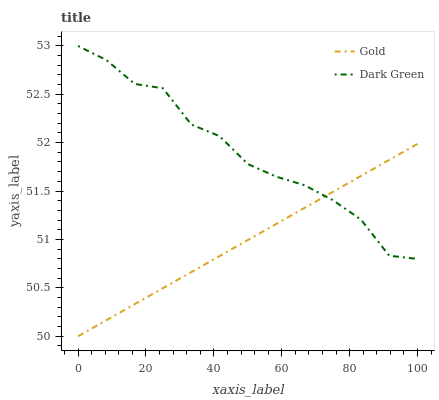Does Gold have the minimum area under the curve?
Answer yes or no. Yes. Does Dark Green have the maximum area under the curve?
Answer yes or no. Yes. Does Dark Green have the minimum area under the curve?
Answer yes or no. No. Is Gold the smoothest?
Answer yes or no. Yes. Is Dark Green the roughest?
Answer yes or no. Yes. Is Dark Green the smoothest?
Answer yes or no. No. Does Gold have the lowest value?
Answer yes or no. Yes. Does Dark Green have the lowest value?
Answer yes or no. No. Does Dark Green have the highest value?
Answer yes or no. Yes. Does Dark Green intersect Gold?
Answer yes or no. Yes. Is Dark Green less than Gold?
Answer yes or no. No. Is Dark Green greater than Gold?
Answer yes or no. No. 